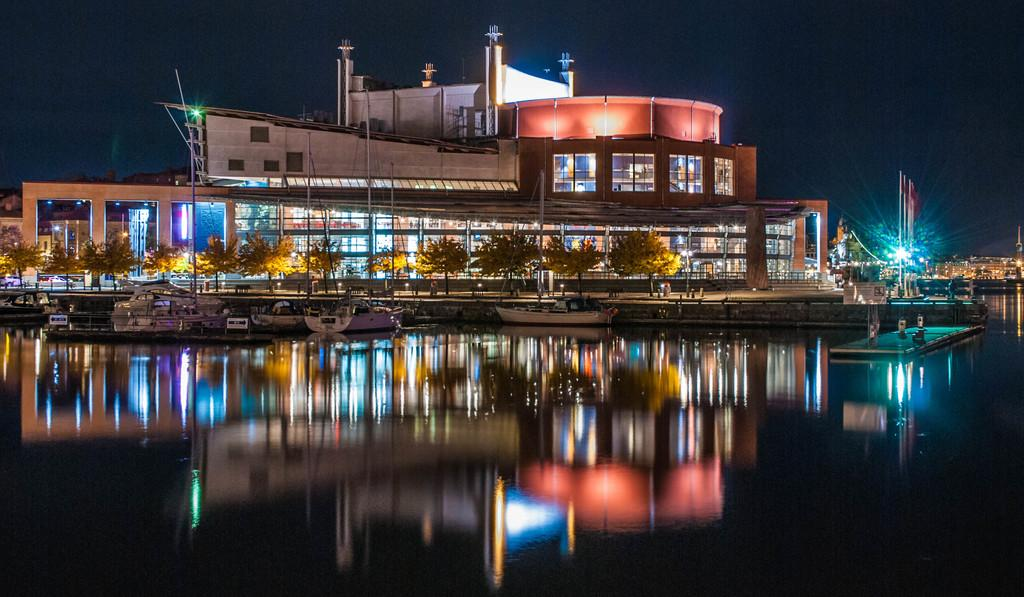What is positioned above the water in the image? There are boats above the water in the image. What type of structures can be seen in the image? There are buildings in the image. What objects are present in the image that might be used for support or guidance? There are poles in the image. What can be seen illuminating the area in the image? There are lights in the image. What type of vegetation is visible in the image? There are trees in the image. How would you describe the sky in the background of the image? The sky in the background is dark. What type of punishment is being administered to the visitor in the image? There is no indication of punishment or a visitor in the image; it features boats, buildings, poles, lights, trees, and a dark sky. 